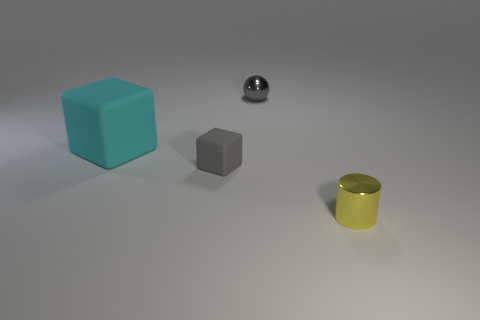Add 4 tiny purple matte cubes. How many objects exist? 8 Subtract all cylinders. How many objects are left? 3 Subtract 0 purple spheres. How many objects are left? 4 Subtract all big green matte balls. Subtract all gray rubber objects. How many objects are left? 3 Add 3 tiny metallic things. How many tiny metallic things are left? 5 Add 3 big green objects. How many big green objects exist? 3 